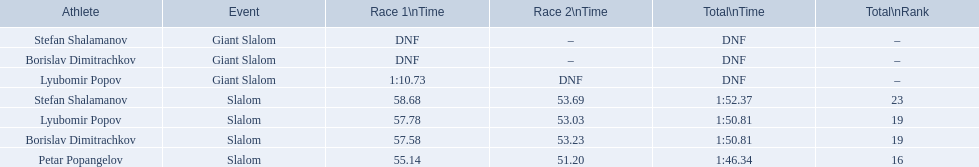In which competition does the giant slalom take place? Giant Slalom, Giant Slalom, Giant Slalom. Who is known as lyubomir popov? Lyubomir Popov. At what time is race 1 scheduled? 1:10.73. 